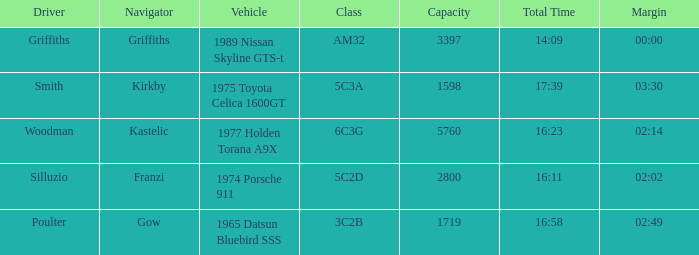Help me parse the entirety of this table. {'header': ['Driver', 'Navigator', 'Vehicle', 'Class', 'Capacity', 'Total Time', 'Margin'], 'rows': [['Griffiths', 'Griffiths', '1989 Nissan Skyline GTS-t', 'AM32', '3397', '14:09', '00:00'], ['Smith', 'Kirkby', '1975 Toyota Celica 1600GT', '5C3A', '1598', '17:39', '03:30'], ['Woodman', 'Kastelic', '1977 Holden Torana A9X', '6C3G', '5760', '16:23', '02:14'], ['Silluzio', 'Franzi', '1974 Porsche 911', '5C2D', '2800', '16:11', '02:02'], ['Poulter', 'Gow', '1965 Datsun Bluebird SSS', '3C2B', '1719', '16:58', '02:49']]} What's the lowest capacity when the margin is 03:30? 1598.0. 